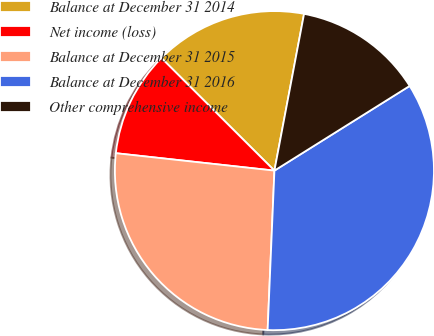Convert chart. <chart><loc_0><loc_0><loc_500><loc_500><pie_chart><fcel>Balance at December 31 2014<fcel>Net income (loss)<fcel>Balance at December 31 2015<fcel>Balance at December 31 2016<fcel>Other comprehensive income<nl><fcel>15.5%<fcel>10.73%<fcel>26.06%<fcel>34.58%<fcel>13.12%<nl></chart> 